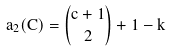Convert formula to latex. <formula><loc_0><loc_0><loc_500><loc_500>a _ { 2 } ( C ) = { { c + 1 } \choose { 2 } } + 1 - k</formula> 